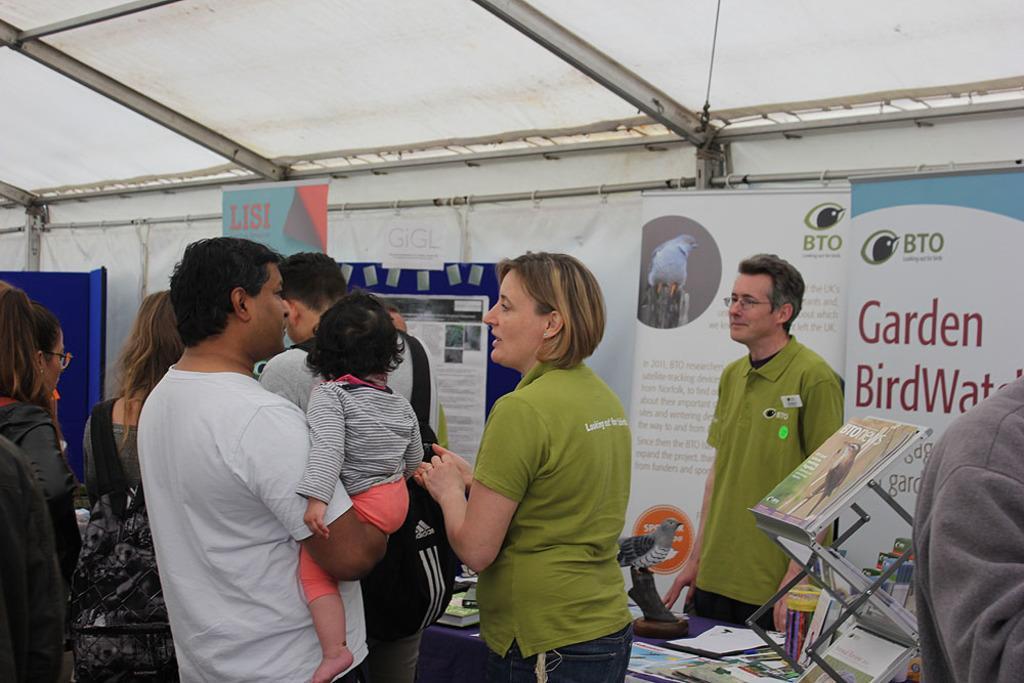Please provide a concise description of this image. In this image there are people standing and there are also two people with light green t shirts. In the background there are banners of BTO. At the top there is a roof for shelter. There are also books, papers, bird object placed on the blue color cloth of the table. 